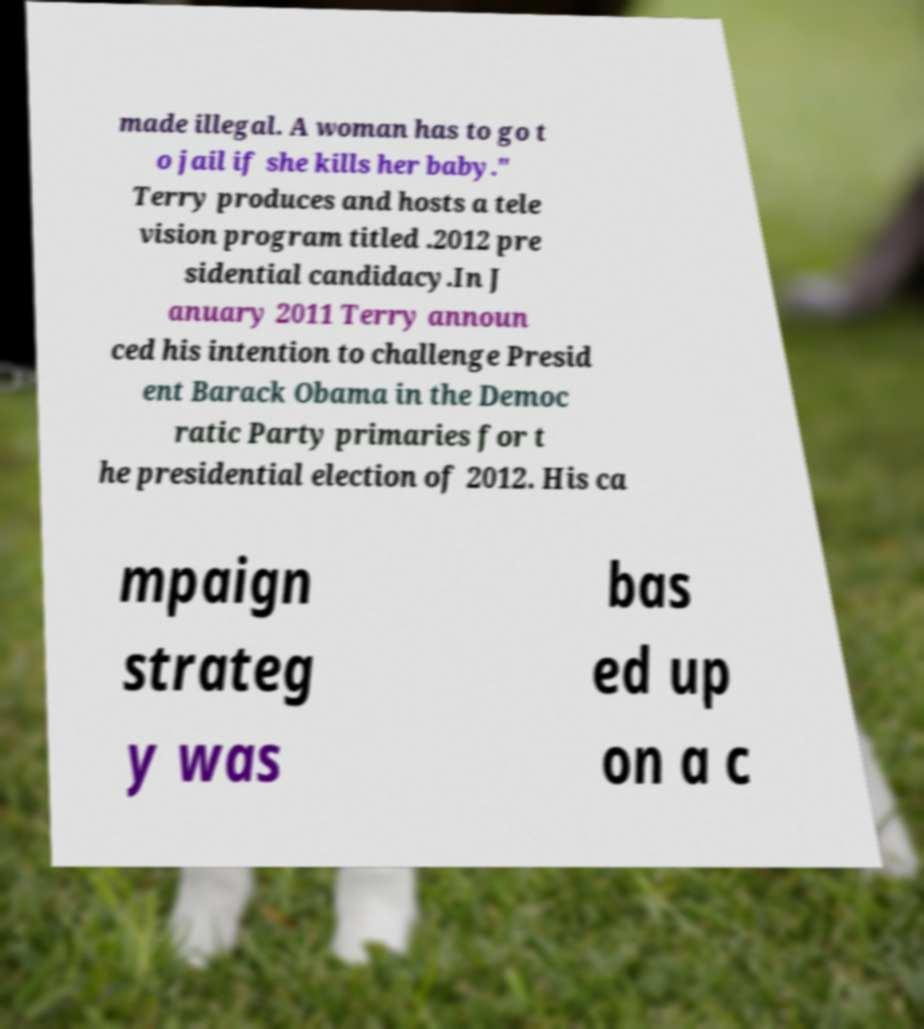Could you assist in decoding the text presented in this image and type it out clearly? made illegal. A woman has to go t o jail if she kills her baby." Terry produces and hosts a tele vision program titled .2012 pre sidential candidacy.In J anuary 2011 Terry announ ced his intention to challenge Presid ent Barack Obama in the Democ ratic Party primaries for t he presidential election of 2012. His ca mpaign strateg y was bas ed up on a c 